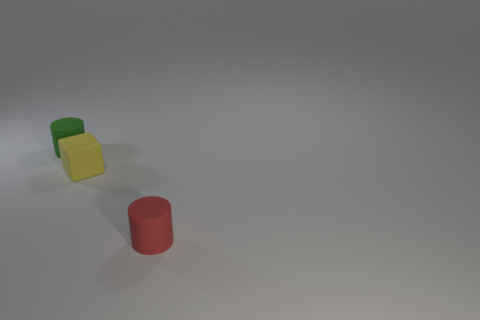Add 2 red cylinders. How many objects exist? 5 Subtract all red cylinders. How many cylinders are left? 1 Subtract all purple matte objects. Subtract all red matte cylinders. How many objects are left? 2 Add 1 yellow cubes. How many yellow cubes are left? 2 Add 1 large brown shiny objects. How many large brown shiny objects exist? 1 Subtract 0 gray spheres. How many objects are left? 3 Subtract all cylinders. How many objects are left? 1 Subtract all green cylinders. Subtract all yellow balls. How many cylinders are left? 1 